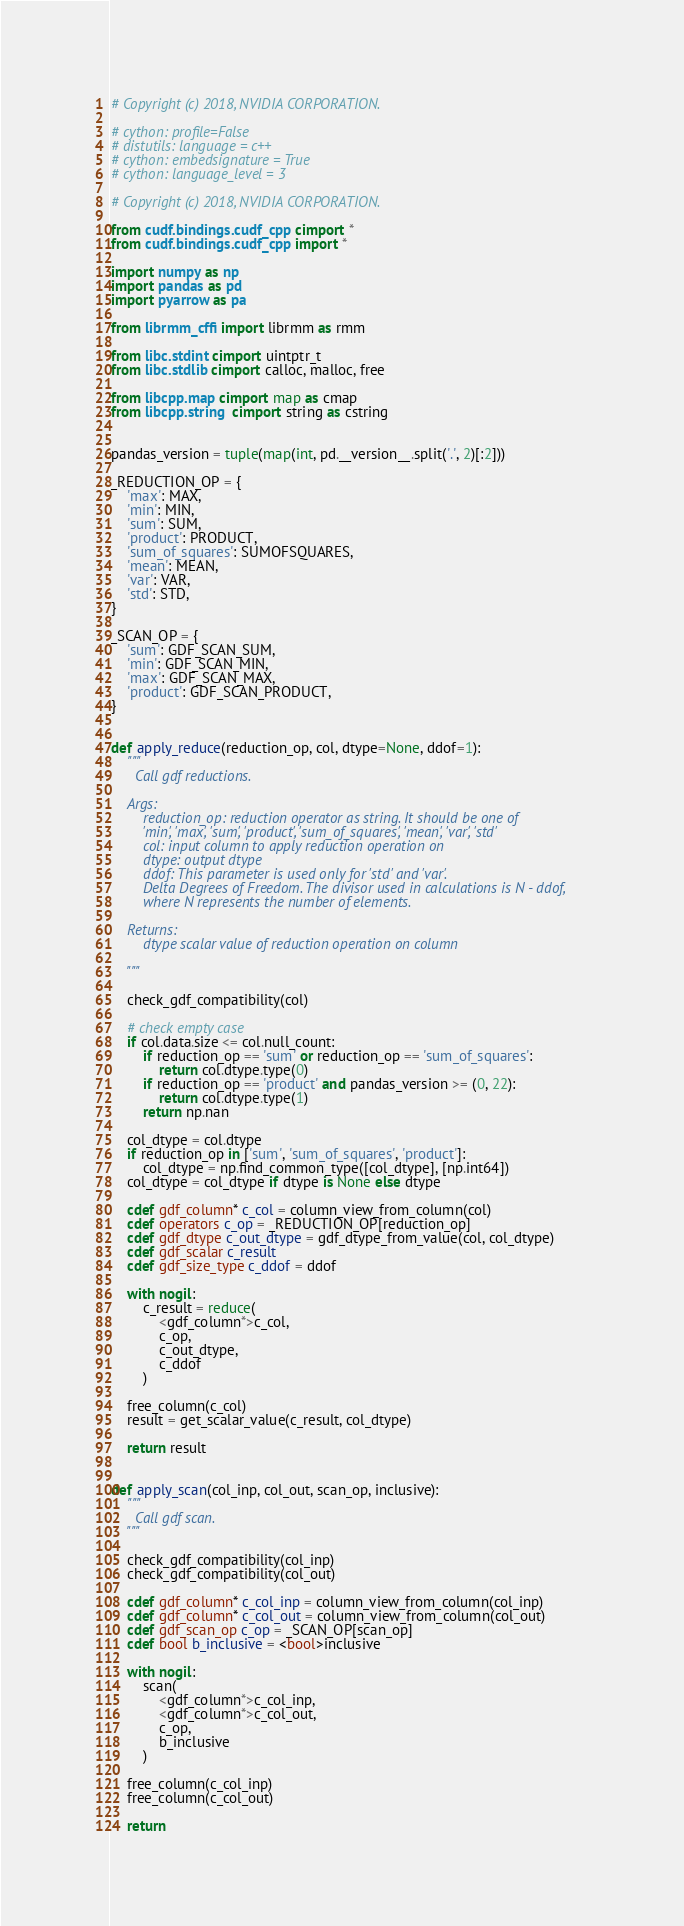<code> <loc_0><loc_0><loc_500><loc_500><_Cython_># Copyright (c) 2018, NVIDIA CORPORATION.

# cython: profile=False
# distutils: language = c++
# cython: embedsignature = True
# cython: language_level = 3

# Copyright (c) 2018, NVIDIA CORPORATION.

from cudf.bindings.cudf_cpp cimport *
from cudf.bindings.cudf_cpp import *

import numpy as np
import pandas as pd
import pyarrow as pa

from librmm_cffi import librmm as rmm

from libc.stdint cimport uintptr_t
from libc.stdlib cimport calloc, malloc, free

from libcpp.map cimport map as cmap
from libcpp.string  cimport string as cstring


pandas_version = tuple(map(int, pd.__version__.split('.', 2)[:2]))

_REDUCTION_OP = {
    'max': MAX,
    'min': MIN,
    'sum': SUM,
    'product': PRODUCT,
    'sum_of_squares': SUMOFSQUARES,
    'mean': MEAN,
    'var': VAR,
    'std': STD,
}

_SCAN_OP = {
    'sum': GDF_SCAN_SUM,
    'min': GDF_SCAN_MIN,
    'max': GDF_SCAN_MAX,
    'product': GDF_SCAN_PRODUCT,
}


def apply_reduce(reduction_op, col, dtype=None, ddof=1):
    """
      Call gdf reductions.

    Args:
        reduction_op: reduction operator as string. It should be one of
        'min', 'max', 'sum', 'product', 'sum_of_squares', 'mean', 'var', 'std'
        col: input column to apply reduction operation on
        dtype: output dtype
        ddof: This parameter is used only for 'std' and 'var'.
        Delta Degrees of Freedom. The divisor used in calculations is N - ddof,
        where N represents the number of elements.

    Returns:
        dtype scalar value of reduction operation on column

    """

    check_gdf_compatibility(col)

    # check empty case
    if col.data.size <= col.null_count:
        if reduction_op == 'sum' or reduction_op == 'sum_of_squares':
            return col.dtype.type(0)
        if reduction_op == 'product' and pandas_version >= (0, 22):
            return col.dtype.type(1)
        return np.nan

    col_dtype = col.dtype
    if reduction_op in ['sum', 'sum_of_squares', 'product']:
        col_dtype = np.find_common_type([col_dtype], [np.int64])
    col_dtype = col_dtype if dtype is None else dtype

    cdef gdf_column* c_col = column_view_from_column(col)
    cdef operators c_op = _REDUCTION_OP[reduction_op]
    cdef gdf_dtype c_out_dtype = gdf_dtype_from_value(col, col_dtype)
    cdef gdf_scalar c_result
    cdef gdf_size_type c_ddof = ddof

    with nogil:
        c_result = reduce(
            <gdf_column*>c_col,
            c_op,
            c_out_dtype,
            c_ddof
        )

    free_column(c_col)
    result = get_scalar_value(c_result, col_dtype)

    return result


def apply_scan(col_inp, col_out, scan_op, inclusive):
    """
      Call gdf scan.
    """

    check_gdf_compatibility(col_inp)
    check_gdf_compatibility(col_out)

    cdef gdf_column* c_col_inp = column_view_from_column(col_inp)
    cdef gdf_column* c_col_out = column_view_from_column(col_out)
    cdef gdf_scan_op c_op = _SCAN_OP[scan_op]
    cdef bool b_inclusive = <bool>inclusive

    with nogil:
        scan(
            <gdf_column*>c_col_inp,
            <gdf_column*>c_col_out,
            c_op,
            b_inclusive
        )

    free_column(c_col_inp)
    free_column(c_col_out)

    return
</code> 